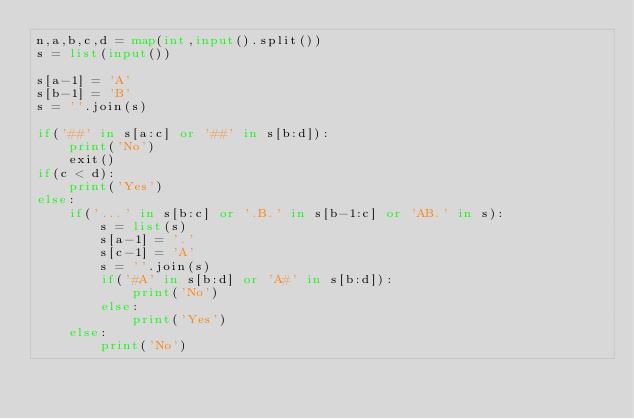Convert code to text. <code><loc_0><loc_0><loc_500><loc_500><_Python_>n,a,b,c,d = map(int,input().split())
s = list(input())

s[a-1] = 'A'
s[b-1] = 'B'
s = ''.join(s)

if('##' in s[a:c] or '##' in s[b:d]):
    print('No')
    exit()
if(c < d):
    print('Yes')
else:
    if('...' in s[b:c] or '.B.' in s[b-1:c] or 'AB.' in s):
        s = list(s)
        s[a-1] = '.'
        s[c-1] = 'A'
        s = ''.join(s)
        if('#A' in s[b:d] or 'A#' in s[b:d]):
            print('No')
        else:
            print('Yes')
    else:
        print('No')
</code> 